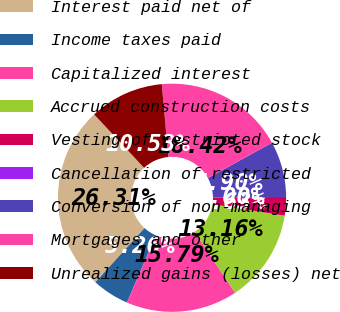Convert chart. <chart><loc_0><loc_0><loc_500><loc_500><pie_chart><fcel>Interest paid net of<fcel>Income taxes paid<fcel>Capitalized interest<fcel>Accrued construction costs<fcel>Vesting of restricted stock<fcel>Cancellation of restricted<fcel>Conversion of non-managing<fcel>Mortgages and other<fcel>Unrealized gains (losses) net<nl><fcel>26.31%<fcel>5.26%<fcel>15.79%<fcel>13.16%<fcel>2.63%<fcel>0.0%<fcel>7.9%<fcel>18.42%<fcel>10.53%<nl></chart> 